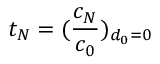<formula> <loc_0><loc_0><loc_500><loc_500>t _ { N } = ( \frac { c _ { N } } { c _ { 0 } } ) _ { d _ { 0 } = 0 }</formula> 